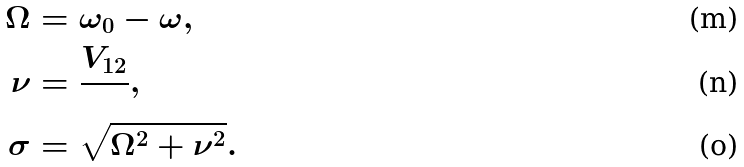<formula> <loc_0><loc_0><loc_500><loc_500>\Omega & = \omega _ { 0 } - \omega , \\ \nu & = \frac { V _ { 1 2 } } { } , \\ \sigma & = \sqrt { \Omega ^ { 2 } + \nu ^ { 2 } } .</formula> 